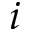<formula> <loc_0><loc_0><loc_500><loc_500>i</formula> 